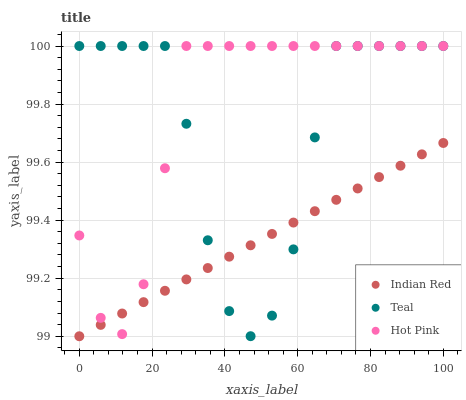Does Indian Red have the minimum area under the curve?
Answer yes or no. Yes. Does Hot Pink have the maximum area under the curve?
Answer yes or no. Yes. Does Teal have the minimum area under the curve?
Answer yes or no. No. Does Teal have the maximum area under the curve?
Answer yes or no. No. Is Indian Red the smoothest?
Answer yes or no. Yes. Is Teal the roughest?
Answer yes or no. Yes. Is Teal the smoothest?
Answer yes or no. No. Is Indian Red the roughest?
Answer yes or no. No. Does Indian Red have the lowest value?
Answer yes or no. Yes. Does Teal have the lowest value?
Answer yes or no. No. Does Teal have the highest value?
Answer yes or no. Yes. Does Indian Red have the highest value?
Answer yes or no. No. Does Indian Red intersect Teal?
Answer yes or no. Yes. Is Indian Red less than Teal?
Answer yes or no. No. Is Indian Red greater than Teal?
Answer yes or no. No. 